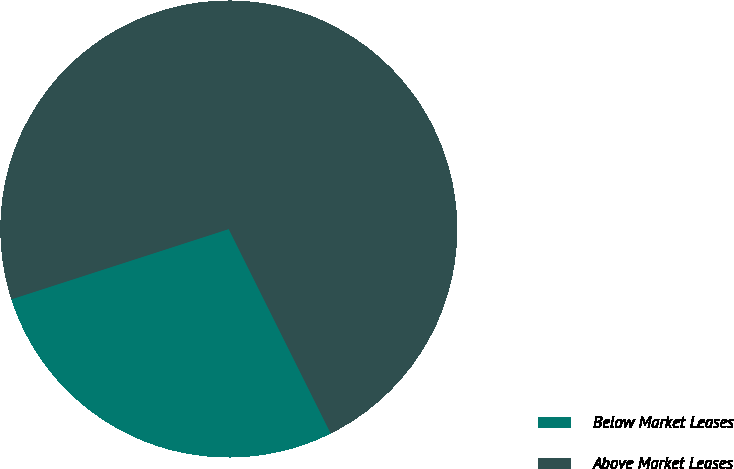Convert chart. <chart><loc_0><loc_0><loc_500><loc_500><pie_chart><fcel>Below Market Leases<fcel>Above Market Leases<nl><fcel>27.39%<fcel>72.61%<nl></chart> 